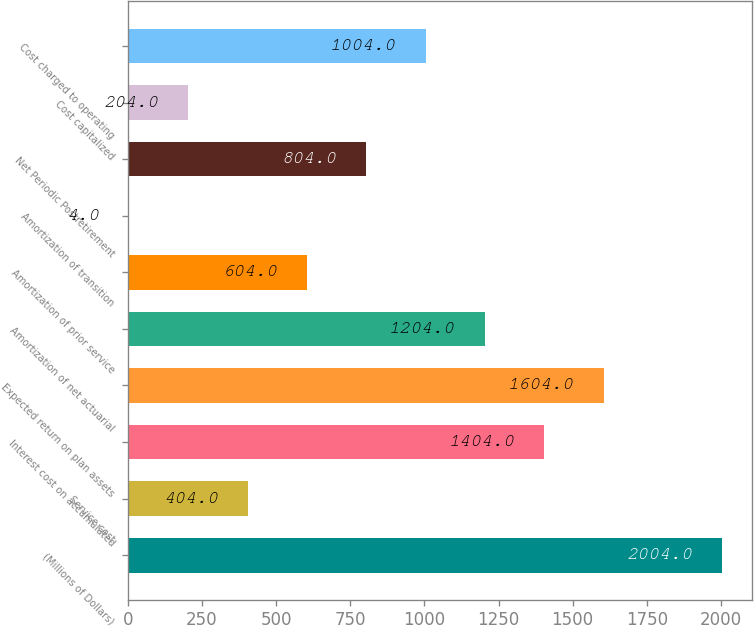Convert chart to OTSL. <chart><loc_0><loc_0><loc_500><loc_500><bar_chart><fcel>(Millions of Dollars)<fcel>Service cost<fcel>Interest cost on accumulated<fcel>Expected return on plan assets<fcel>Amortization of net actuarial<fcel>Amortization of prior service<fcel>Amortization of transition<fcel>Net Periodic Postretirement<fcel>Cost capitalized<fcel>Cost charged to operating<nl><fcel>2004<fcel>404<fcel>1404<fcel>1604<fcel>1204<fcel>604<fcel>4<fcel>804<fcel>204<fcel>1004<nl></chart> 